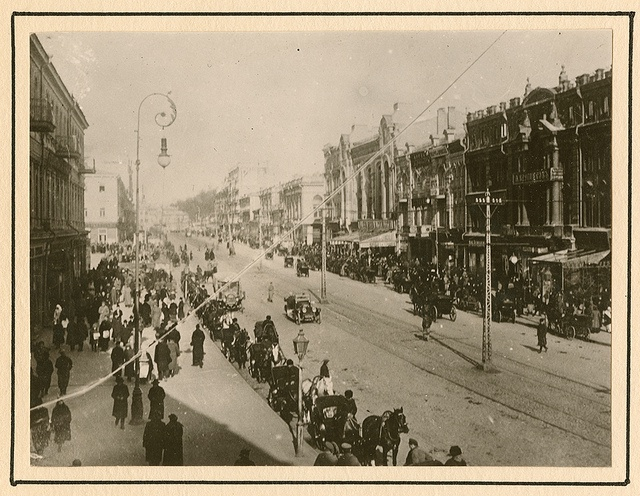Describe the objects in this image and their specific colors. I can see people in tan, black, darkgreen, and gray tones, horse in tan, black, darkgreen, and gray tones, car in tan and gray tones, people in tan, black, darkgreen, and gray tones, and car in tan, gray, and black tones in this image. 